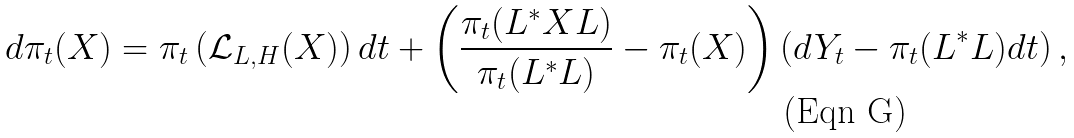<formula> <loc_0><loc_0><loc_500><loc_500>d \pi _ { t } ( X ) = \pi _ { t } \left ( \mathcal { L } _ { L , H } ( X ) \right ) d t + \left ( \frac { \pi _ { t } ( L ^ { * } X L ) } { \pi _ { t } ( L ^ { * } L ) } - \pi _ { t } ( X ) \right ) \left ( d Y _ { t } - \pi _ { t } ( L ^ { * } L ) d t \right ) ,</formula> 